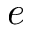<formula> <loc_0><loc_0><loc_500><loc_500>e</formula> 